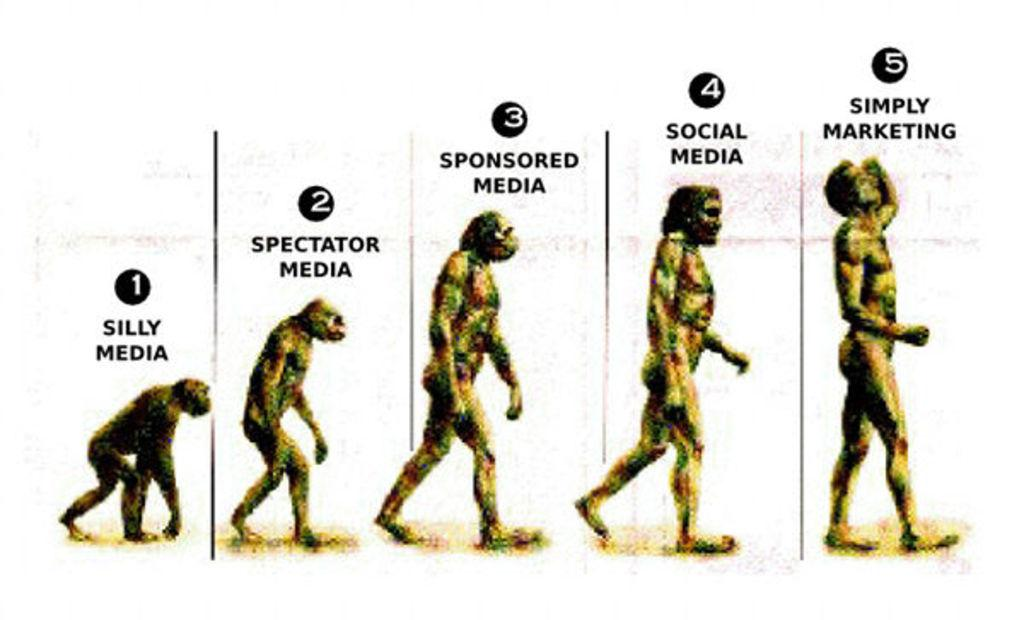What is the main subject of the image? The main subject of the image is five stages of early man. Can you describe any additional elements in the image? Yes, there is text and numbers at the top of the image. What type of skin is visible on the early man in the image? There is no specific information about the skin of the early man in the image, as the focus is on the stages of early man and not their physical appearance. 